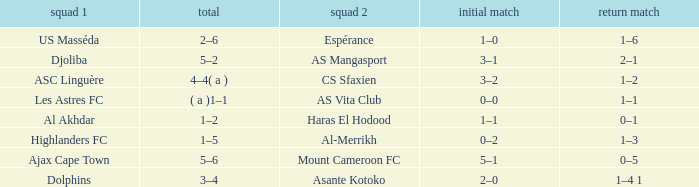What is the team 1 with team 2 Mount Cameroon FC? Ajax Cape Town. 